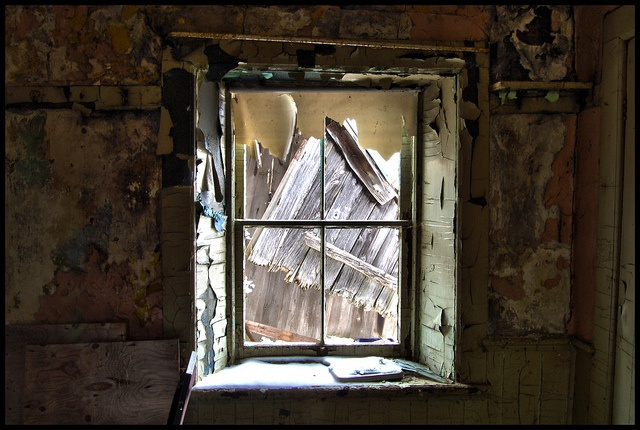Describe the objects in this image and their specific colors. I can see a book in black, white, lavender, and lightblue tones in this image. 